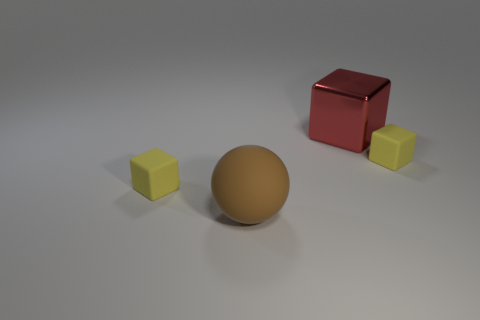Are there any other things that have the same material as the big red block?
Your answer should be compact. No. How many rubber balls have the same color as the metallic object?
Provide a short and direct response. 0. How many objects are small cyan rubber cylinders or small objects?
Ensure brevity in your answer.  2. What material is the big red block behind the tiny rubber cube to the left of the big matte sphere made of?
Offer a terse response. Metal. Are there any large objects made of the same material as the big brown sphere?
Offer a terse response. No. There is a tiny object behind the small thing that is to the left of the object that is to the right of the red block; what shape is it?
Offer a terse response. Cube. What material is the large brown sphere?
Your answer should be very brief. Rubber. Are there any yellow rubber cubes to the right of the tiny cube that is left of the large brown matte ball?
Your answer should be compact. Yes. What number of other objects are there of the same shape as the large red object?
Make the answer very short. 2. Does the object to the left of the large rubber thing have the same shape as the matte object that is to the right of the brown object?
Your answer should be compact. Yes. 